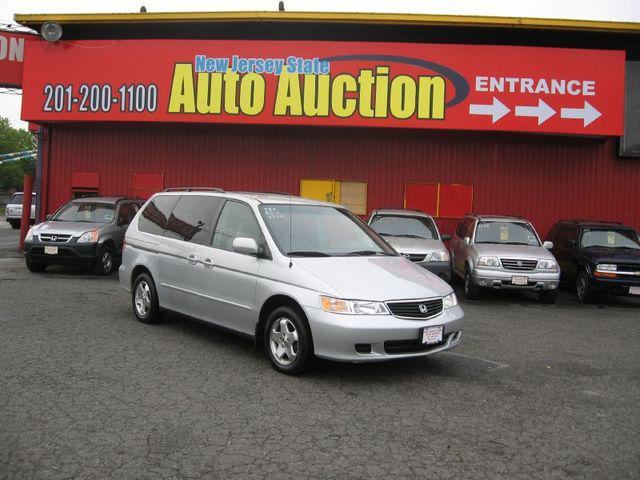What can we infer about the place where these cars are parked? The cars are parked at a business identified as 'New Jersey State Auto Auction,' which suggests it's a public vehicle auction house. From the look of the signs and the variety of cars present, it's likely a place where used cars are sold to the highest bidder. 